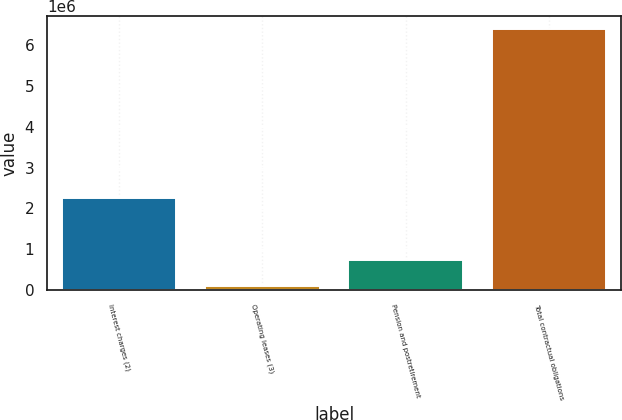Convert chart. <chart><loc_0><loc_0><loc_500><loc_500><bar_chart><fcel>Interest charges (2)<fcel>Operating leases (3)<fcel>Pension and postretirement<fcel>Total contractual obligations<nl><fcel>2.25731e+06<fcel>104191<fcel>731894<fcel>6.38122e+06<nl></chart> 